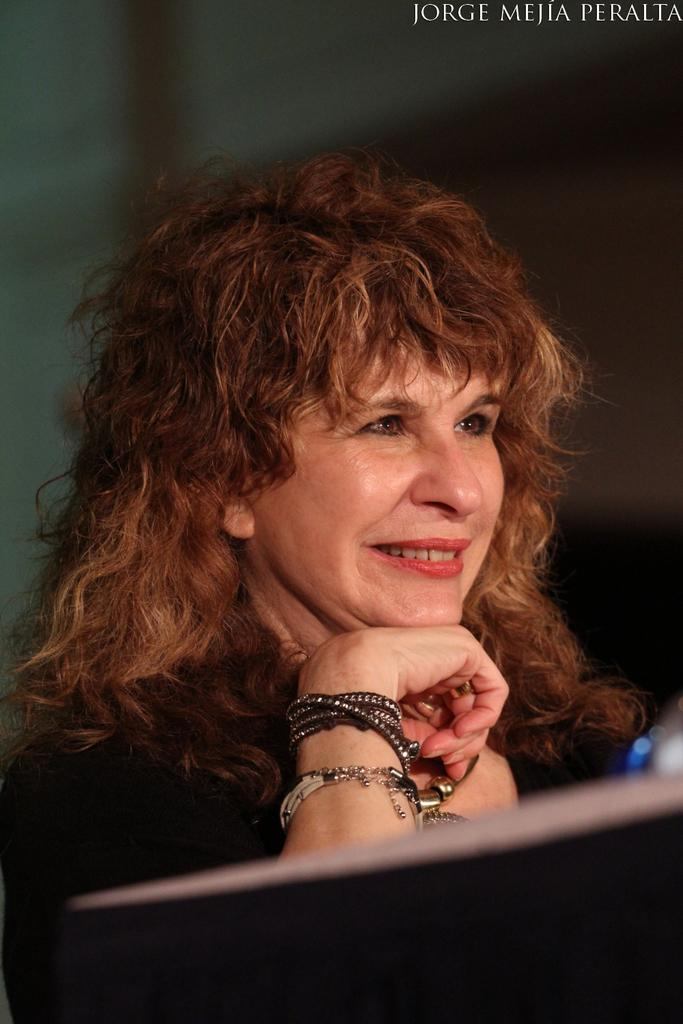Who is present in the image? There is a woman in the image. What is the woman wearing? The woman is wearing a dress. What object can be seen in the foreground of the image? There is a table in the foreground of the image. What can be seen in the background of the image? There is text visible in the background of the image. Where is the rabbit playing in the sand in the image? There is no rabbit or sand present in the image. 